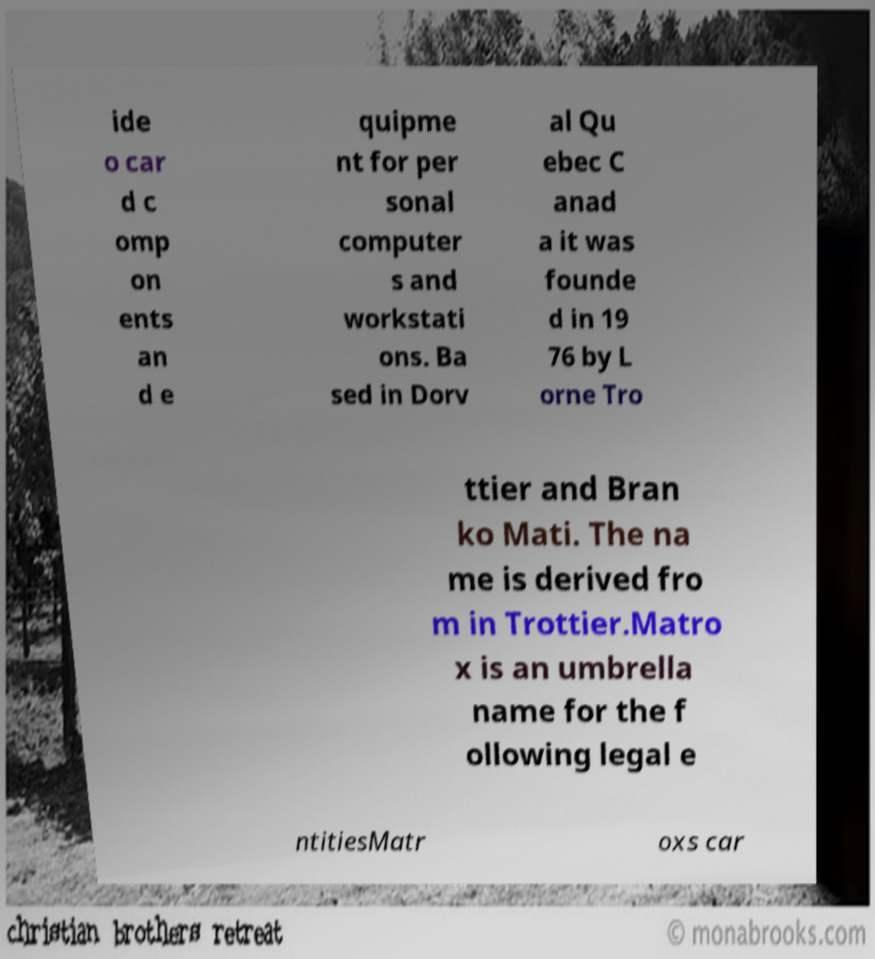There's text embedded in this image that I need extracted. Can you transcribe it verbatim? ide o car d c omp on ents an d e quipme nt for per sonal computer s and workstati ons. Ba sed in Dorv al Qu ebec C anad a it was founde d in 19 76 by L orne Tro ttier and Bran ko Mati. The na me is derived fro m in Trottier.Matro x is an umbrella name for the f ollowing legal e ntitiesMatr oxs car 